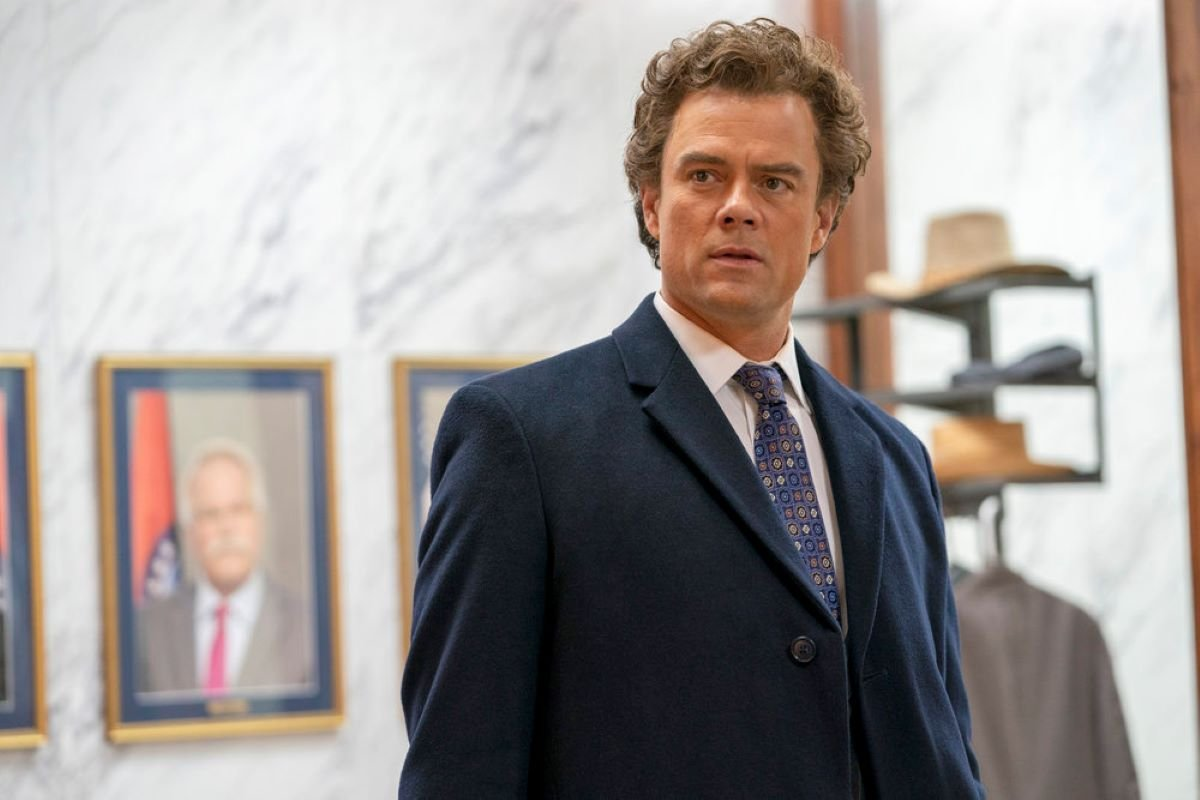Explain the visual content of the image in great detail. The image captures a man in a formal setting, specifically what appears to be a sophisticated office or a public space. Dressed in a dark blue suit complemented by a patterned tie, the subject stands with a pensive expression. His gaze is directed slightly off-camera, adding to the contemplative mood conveyed by his slight frown and furrowed brows. The backdrop includes a wall of polished white marble, adorned with framed photographs or certificates that suggest a professional or ceremonial environment. Notably, there is a hat rack visible in the background, indicating an element that suggests regular human activity and movement within this space. This setting and attire hint that the individual depicted might be a figure of authority or involved in significant professional roles. 